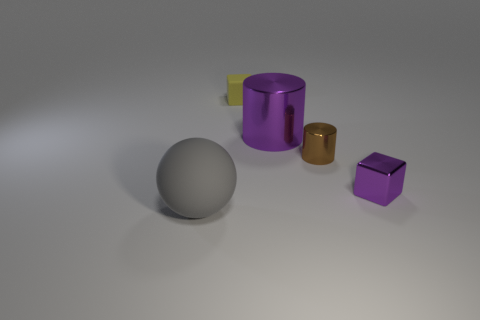What shape is the shiny thing that is the same color as the metallic block?
Offer a terse response. Cylinder. Is the tiny metallic block the same color as the large shiny cylinder?
Your answer should be compact. Yes. Is the number of yellow blocks that are on the left side of the yellow matte cube greater than the number of small purple blocks?
Provide a short and direct response. No. What number of other things are there of the same material as the tiny purple block
Offer a very short reply. 2. What number of large things are either purple cylinders or gray shiny cubes?
Provide a short and direct response. 1. Are the small cylinder and the big cylinder made of the same material?
Make the answer very short. Yes. What number of shiny blocks are in front of the small cube that is in front of the rubber cube?
Provide a short and direct response. 0. Is there another big matte thing that has the same shape as the gray thing?
Make the answer very short. No. There is a large thing that is behind the big gray object; is its shape the same as the rubber thing in front of the tiny rubber block?
Provide a succinct answer. No. What shape is the thing that is left of the brown metallic thing and in front of the small brown shiny thing?
Ensure brevity in your answer.  Sphere. 